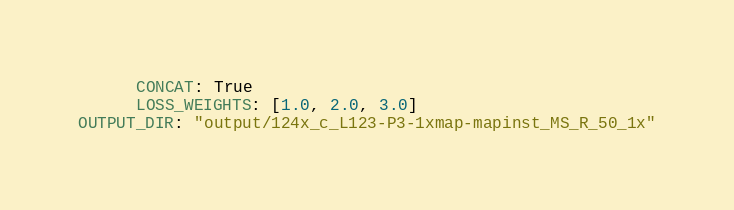Convert code to text. <code><loc_0><loc_0><loc_500><loc_500><_YAML_>      CONCAT: True
      LOSS_WEIGHTS: [1.0, 2.0, 3.0]
OUTPUT_DIR: "output/124x_c_L123-P3-1xmap-mapinst_MS_R_50_1x"
</code> 